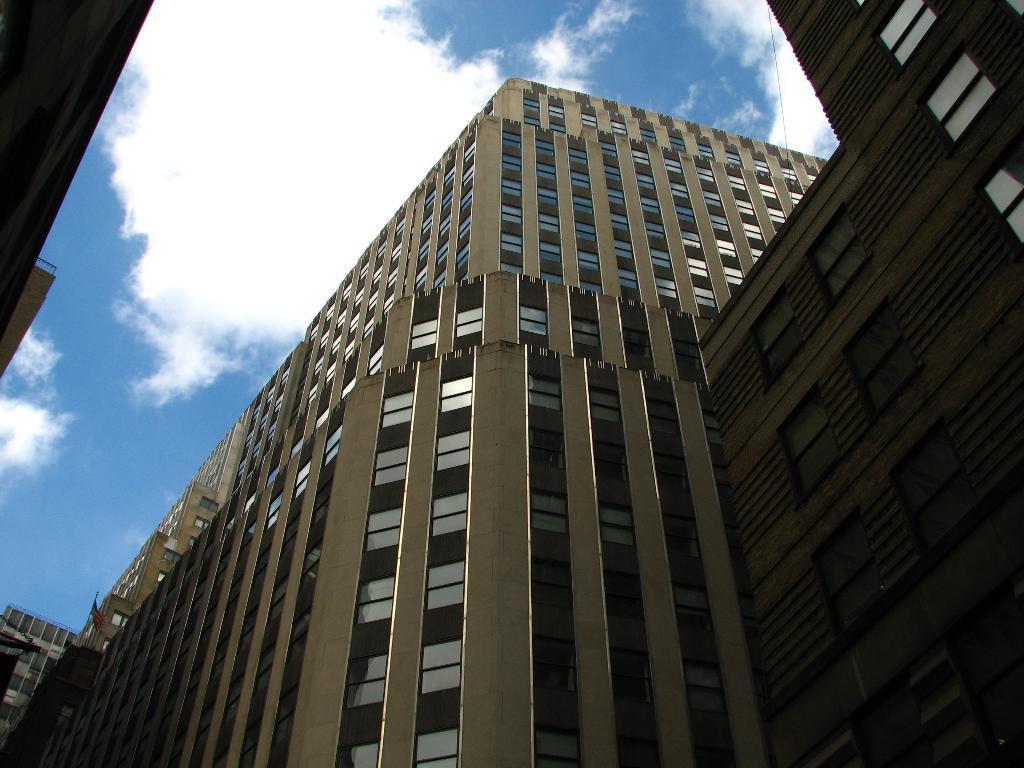Could you give a brief overview of what you see in this image? In this image I can see the buildings. On the top of the image I can see the sky and clouds. 